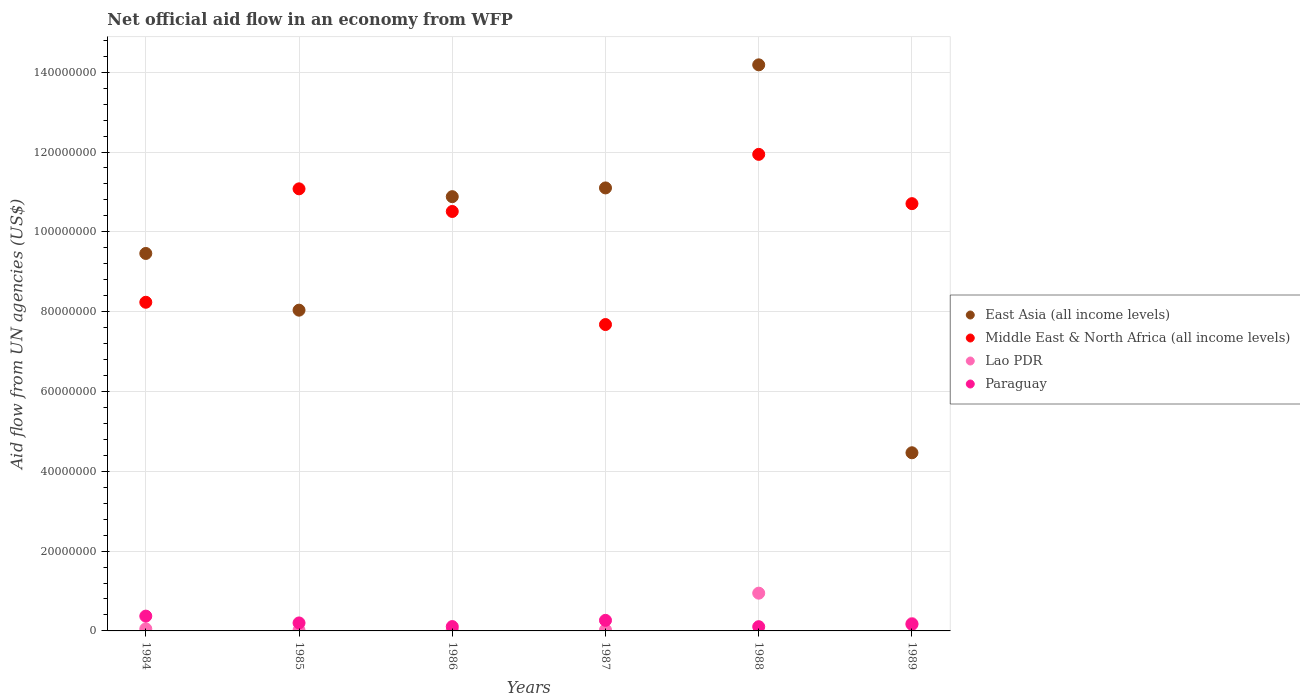Is the number of dotlines equal to the number of legend labels?
Make the answer very short. Yes. What is the net official aid flow in Paraguay in 1989?
Offer a terse response. 1.66e+06. Across all years, what is the maximum net official aid flow in Lao PDR?
Your answer should be very brief. 9.46e+06. Across all years, what is the minimum net official aid flow in Middle East & North Africa (all income levels)?
Your answer should be compact. 7.68e+07. In which year was the net official aid flow in Paraguay minimum?
Offer a terse response. 1988. What is the total net official aid flow in Lao PDR in the graph?
Offer a very short reply. 1.25e+07. What is the difference between the net official aid flow in Middle East & North Africa (all income levels) in 1987 and that in 1989?
Give a very brief answer. -3.03e+07. What is the difference between the net official aid flow in East Asia (all income levels) in 1984 and the net official aid flow in Middle East & North Africa (all income levels) in 1988?
Provide a succinct answer. -2.48e+07. What is the average net official aid flow in Lao PDR per year?
Ensure brevity in your answer.  2.09e+06. In the year 1986, what is the difference between the net official aid flow in East Asia (all income levels) and net official aid flow in Paraguay?
Offer a terse response. 1.08e+08. In how many years, is the net official aid flow in Middle East & North Africa (all income levels) greater than 128000000 US$?
Provide a succinct answer. 0. What is the ratio of the net official aid flow in Middle East & North Africa (all income levels) in 1986 to that in 1987?
Your answer should be compact. 1.37. Is the difference between the net official aid flow in East Asia (all income levels) in 1984 and 1987 greater than the difference between the net official aid flow in Paraguay in 1984 and 1987?
Make the answer very short. No. What is the difference between the highest and the second highest net official aid flow in Lao PDR?
Give a very brief answer. 7.60e+06. What is the difference between the highest and the lowest net official aid flow in Lao PDR?
Your response must be concise. 9.28e+06. In how many years, is the net official aid flow in Lao PDR greater than the average net official aid flow in Lao PDR taken over all years?
Give a very brief answer. 1. Does the net official aid flow in Middle East & North Africa (all income levels) monotonically increase over the years?
Provide a succinct answer. No. Is the net official aid flow in East Asia (all income levels) strictly greater than the net official aid flow in Middle East & North Africa (all income levels) over the years?
Your response must be concise. No. How many dotlines are there?
Provide a succinct answer. 4. How many years are there in the graph?
Offer a terse response. 6. What is the difference between two consecutive major ticks on the Y-axis?
Keep it short and to the point. 2.00e+07. Are the values on the major ticks of Y-axis written in scientific E-notation?
Provide a short and direct response. No. What is the title of the graph?
Keep it short and to the point. Net official aid flow in an economy from WFP. Does "Niger" appear as one of the legend labels in the graph?
Your response must be concise. No. What is the label or title of the Y-axis?
Provide a short and direct response. Aid flow from UN agencies (US$). What is the Aid flow from UN agencies (US$) of East Asia (all income levels) in 1984?
Keep it short and to the point. 9.46e+07. What is the Aid flow from UN agencies (US$) in Middle East & North Africa (all income levels) in 1984?
Offer a terse response. 8.24e+07. What is the Aid flow from UN agencies (US$) in Lao PDR in 1984?
Give a very brief answer. 5.20e+05. What is the Aid flow from UN agencies (US$) of Paraguay in 1984?
Your answer should be compact. 3.71e+06. What is the Aid flow from UN agencies (US$) in East Asia (all income levels) in 1985?
Ensure brevity in your answer.  8.04e+07. What is the Aid flow from UN agencies (US$) in Middle East & North Africa (all income levels) in 1985?
Make the answer very short. 1.11e+08. What is the Aid flow from UN agencies (US$) in Lao PDR in 1985?
Keep it short and to the point. 1.80e+05. What is the Aid flow from UN agencies (US$) of Paraguay in 1985?
Ensure brevity in your answer.  2.00e+06. What is the Aid flow from UN agencies (US$) in East Asia (all income levels) in 1986?
Keep it short and to the point. 1.09e+08. What is the Aid flow from UN agencies (US$) in Middle East & North Africa (all income levels) in 1986?
Your response must be concise. 1.05e+08. What is the Aid flow from UN agencies (US$) in Lao PDR in 1986?
Provide a succinct answer. 2.60e+05. What is the Aid flow from UN agencies (US$) of Paraguay in 1986?
Offer a terse response. 1.09e+06. What is the Aid flow from UN agencies (US$) of East Asia (all income levels) in 1987?
Your response must be concise. 1.11e+08. What is the Aid flow from UN agencies (US$) of Middle East & North Africa (all income levels) in 1987?
Ensure brevity in your answer.  7.68e+07. What is the Aid flow from UN agencies (US$) in Lao PDR in 1987?
Provide a short and direct response. 2.50e+05. What is the Aid flow from UN agencies (US$) in Paraguay in 1987?
Provide a succinct answer. 2.65e+06. What is the Aid flow from UN agencies (US$) of East Asia (all income levels) in 1988?
Your answer should be compact. 1.42e+08. What is the Aid flow from UN agencies (US$) in Middle East & North Africa (all income levels) in 1988?
Ensure brevity in your answer.  1.19e+08. What is the Aid flow from UN agencies (US$) in Lao PDR in 1988?
Make the answer very short. 9.46e+06. What is the Aid flow from UN agencies (US$) in Paraguay in 1988?
Your answer should be compact. 1.06e+06. What is the Aid flow from UN agencies (US$) in East Asia (all income levels) in 1989?
Ensure brevity in your answer.  4.46e+07. What is the Aid flow from UN agencies (US$) in Middle East & North Africa (all income levels) in 1989?
Offer a terse response. 1.07e+08. What is the Aid flow from UN agencies (US$) of Lao PDR in 1989?
Give a very brief answer. 1.86e+06. What is the Aid flow from UN agencies (US$) of Paraguay in 1989?
Your answer should be very brief. 1.66e+06. Across all years, what is the maximum Aid flow from UN agencies (US$) of East Asia (all income levels)?
Keep it short and to the point. 1.42e+08. Across all years, what is the maximum Aid flow from UN agencies (US$) in Middle East & North Africa (all income levels)?
Your response must be concise. 1.19e+08. Across all years, what is the maximum Aid flow from UN agencies (US$) in Lao PDR?
Your response must be concise. 9.46e+06. Across all years, what is the maximum Aid flow from UN agencies (US$) of Paraguay?
Provide a succinct answer. 3.71e+06. Across all years, what is the minimum Aid flow from UN agencies (US$) in East Asia (all income levels)?
Keep it short and to the point. 4.46e+07. Across all years, what is the minimum Aid flow from UN agencies (US$) of Middle East & North Africa (all income levels)?
Offer a terse response. 7.68e+07. Across all years, what is the minimum Aid flow from UN agencies (US$) in Paraguay?
Your answer should be compact. 1.06e+06. What is the total Aid flow from UN agencies (US$) in East Asia (all income levels) in the graph?
Your answer should be compact. 5.81e+08. What is the total Aid flow from UN agencies (US$) of Middle East & North Africa (all income levels) in the graph?
Your answer should be very brief. 6.01e+08. What is the total Aid flow from UN agencies (US$) of Lao PDR in the graph?
Provide a short and direct response. 1.25e+07. What is the total Aid flow from UN agencies (US$) of Paraguay in the graph?
Give a very brief answer. 1.22e+07. What is the difference between the Aid flow from UN agencies (US$) of East Asia (all income levels) in 1984 and that in 1985?
Your answer should be very brief. 1.42e+07. What is the difference between the Aid flow from UN agencies (US$) of Middle East & North Africa (all income levels) in 1984 and that in 1985?
Make the answer very short. -2.84e+07. What is the difference between the Aid flow from UN agencies (US$) of Paraguay in 1984 and that in 1985?
Your response must be concise. 1.71e+06. What is the difference between the Aid flow from UN agencies (US$) of East Asia (all income levels) in 1984 and that in 1986?
Your answer should be compact. -1.42e+07. What is the difference between the Aid flow from UN agencies (US$) in Middle East & North Africa (all income levels) in 1984 and that in 1986?
Give a very brief answer. -2.28e+07. What is the difference between the Aid flow from UN agencies (US$) in Paraguay in 1984 and that in 1986?
Offer a terse response. 2.62e+06. What is the difference between the Aid flow from UN agencies (US$) in East Asia (all income levels) in 1984 and that in 1987?
Give a very brief answer. -1.64e+07. What is the difference between the Aid flow from UN agencies (US$) of Middle East & North Africa (all income levels) in 1984 and that in 1987?
Provide a short and direct response. 5.58e+06. What is the difference between the Aid flow from UN agencies (US$) of Lao PDR in 1984 and that in 1987?
Provide a succinct answer. 2.70e+05. What is the difference between the Aid flow from UN agencies (US$) in Paraguay in 1984 and that in 1987?
Offer a terse response. 1.06e+06. What is the difference between the Aid flow from UN agencies (US$) in East Asia (all income levels) in 1984 and that in 1988?
Your answer should be very brief. -4.73e+07. What is the difference between the Aid flow from UN agencies (US$) in Middle East & North Africa (all income levels) in 1984 and that in 1988?
Make the answer very short. -3.71e+07. What is the difference between the Aid flow from UN agencies (US$) in Lao PDR in 1984 and that in 1988?
Your answer should be compact. -8.94e+06. What is the difference between the Aid flow from UN agencies (US$) of Paraguay in 1984 and that in 1988?
Make the answer very short. 2.65e+06. What is the difference between the Aid flow from UN agencies (US$) in East Asia (all income levels) in 1984 and that in 1989?
Your answer should be very brief. 4.99e+07. What is the difference between the Aid flow from UN agencies (US$) in Middle East & North Africa (all income levels) in 1984 and that in 1989?
Ensure brevity in your answer.  -2.47e+07. What is the difference between the Aid flow from UN agencies (US$) in Lao PDR in 1984 and that in 1989?
Provide a succinct answer. -1.34e+06. What is the difference between the Aid flow from UN agencies (US$) of Paraguay in 1984 and that in 1989?
Make the answer very short. 2.05e+06. What is the difference between the Aid flow from UN agencies (US$) of East Asia (all income levels) in 1985 and that in 1986?
Your answer should be compact. -2.84e+07. What is the difference between the Aid flow from UN agencies (US$) of Middle East & North Africa (all income levels) in 1985 and that in 1986?
Your response must be concise. 5.67e+06. What is the difference between the Aid flow from UN agencies (US$) in Paraguay in 1985 and that in 1986?
Your answer should be compact. 9.10e+05. What is the difference between the Aid flow from UN agencies (US$) in East Asia (all income levels) in 1985 and that in 1987?
Offer a very short reply. -3.06e+07. What is the difference between the Aid flow from UN agencies (US$) in Middle East & North Africa (all income levels) in 1985 and that in 1987?
Your response must be concise. 3.40e+07. What is the difference between the Aid flow from UN agencies (US$) of Lao PDR in 1985 and that in 1987?
Your answer should be compact. -7.00e+04. What is the difference between the Aid flow from UN agencies (US$) in Paraguay in 1985 and that in 1987?
Offer a terse response. -6.50e+05. What is the difference between the Aid flow from UN agencies (US$) of East Asia (all income levels) in 1985 and that in 1988?
Make the answer very short. -6.15e+07. What is the difference between the Aid flow from UN agencies (US$) in Middle East & North Africa (all income levels) in 1985 and that in 1988?
Provide a short and direct response. -8.64e+06. What is the difference between the Aid flow from UN agencies (US$) in Lao PDR in 1985 and that in 1988?
Make the answer very short. -9.28e+06. What is the difference between the Aid flow from UN agencies (US$) of Paraguay in 1985 and that in 1988?
Offer a terse response. 9.40e+05. What is the difference between the Aid flow from UN agencies (US$) in East Asia (all income levels) in 1985 and that in 1989?
Offer a very short reply. 3.57e+07. What is the difference between the Aid flow from UN agencies (US$) of Middle East & North Africa (all income levels) in 1985 and that in 1989?
Your answer should be compact. 3.71e+06. What is the difference between the Aid flow from UN agencies (US$) of Lao PDR in 1985 and that in 1989?
Provide a short and direct response. -1.68e+06. What is the difference between the Aid flow from UN agencies (US$) in Paraguay in 1985 and that in 1989?
Give a very brief answer. 3.40e+05. What is the difference between the Aid flow from UN agencies (US$) in East Asia (all income levels) in 1986 and that in 1987?
Provide a succinct answer. -2.19e+06. What is the difference between the Aid flow from UN agencies (US$) in Middle East & North Africa (all income levels) in 1986 and that in 1987?
Your answer should be very brief. 2.83e+07. What is the difference between the Aid flow from UN agencies (US$) of Paraguay in 1986 and that in 1987?
Ensure brevity in your answer.  -1.56e+06. What is the difference between the Aid flow from UN agencies (US$) of East Asia (all income levels) in 1986 and that in 1988?
Your response must be concise. -3.30e+07. What is the difference between the Aid flow from UN agencies (US$) in Middle East & North Africa (all income levels) in 1986 and that in 1988?
Provide a succinct answer. -1.43e+07. What is the difference between the Aid flow from UN agencies (US$) in Lao PDR in 1986 and that in 1988?
Make the answer very short. -9.20e+06. What is the difference between the Aid flow from UN agencies (US$) in East Asia (all income levels) in 1986 and that in 1989?
Offer a very short reply. 6.42e+07. What is the difference between the Aid flow from UN agencies (US$) in Middle East & North Africa (all income levels) in 1986 and that in 1989?
Offer a terse response. -1.96e+06. What is the difference between the Aid flow from UN agencies (US$) in Lao PDR in 1986 and that in 1989?
Ensure brevity in your answer.  -1.60e+06. What is the difference between the Aid flow from UN agencies (US$) of Paraguay in 1986 and that in 1989?
Provide a short and direct response. -5.70e+05. What is the difference between the Aid flow from UN agencies (US$) in East Asia (all income levels) in 1987 and that in 1988?
Your response must be concise. -3.08e+07. What is the difference between the Aid flow from UN agencies (US$) in Middle East & North Africa (all income levels) in 1987 and that in 1988?
Your response must be concise. -4.26e+07. What is the difference between the Aid flow from UN agencies (US$) in Lao PDR in 1987 and that in 1988?
Provide a succinct answer. -9.21e+06. What is the difference between the Aid flow from UN agencies (US$) of Paraguay in 1987 and that in 1988?
Offer a very short reply. 1.59e+06. What is the difference between the Aid flow from UN agencies (US$) of East Asia (all income levels) in 1987 and that in 1989?
Your response must be concise. 6.64e+07. What is the difference between the Aid flow from UN agencies (US$) in Middle East & North Africa (all income levels) in 1987 and that in 1989?
Your answer should be compact. -3.03e+07. What is the difference between the Aid flow from UN agencies (US$) of Lao PDR in 1987 and that in 1989?
Your answer should be very brief. -1.61e+06. What is the difference between the Aid flow from UN agencies (US$) in Paraguay in 1987 and that in 1989?
Give a very brief answer. 9.90e+05. What is the difference between the Aid flow from UN agencies (US$) of East Asia (all income levels) in 1988 and that in 1989?
Your answer should be compact. 9.72e+07. What is the difference between the Aid flow from UN agencies (US$) of Middle East & North Africa (all income levels) in 1988 and that in 1989?
Keep it short and to the point. 1.24e+07. What is the difference between the Aid flow from UN agencies (US$) in Lao PDR in 1988 and that in 1989?
Your answer should be compact. 7.60e+06. What is the difference between the Aid flow from UN agencies (US$) in Paraguay in 1988 and that in 1989?
Provide a short and direct response. -6.00e+05. What is the difference between the Aid flow from UN agencies (US$) of East Asia (all income levels) in 1984 and the Aid flow from UN agencies (US$) of Middle East & North Africa (all income levels) in 1985?
Offer a terse response. -1.62e+07. What is the difference between the Aid flow from UN agencies (US$) of East Asia (all income levels) in 1984 and the Aid flow from UN agencies (US$) of Lao PDR in 1985?
Offer a terse response. 9.44e+07. What is the difference between the Aid flow from UN agencies (US$) in East Asia (all income levels) in 1984 and the Aid flow from UN agencies (US$) in Paraguay in 1985?
Your response must be concise. 9.26e+07. What is the difference between the Aid flow from UN agencies (US$) in Middle East & North Africa (all income levels) in 1984 and the Aid flow from UN agencies (US$) in Lao PDR in 1985?
Your answer should be very brief. 8.22e+07. What is the difference between the Aid flow from UN agencies (US$) in Middle East & North Africa (all income levels) in 1984 and the Aid flow from UN agencies (US$) in Paraguay in 1985?
Your answer should be very brief. 8.04e+07. What is the difference between the Aid flow from UN agencies (US$) of Lao PDR in 1984 and the Aid flow from UN agencies (US$) of Paraguay in 1985?
Provide a succinct answer. -1.48e+06. What is the difference between the Aid flow from UN agencies (US$) of East Asia (all income levels) in 1984 and the Aid flow from UN agencies (US$) of Middle East & North Africa (all income levels) in 1986?
Ensure brevity in your answer.  -1.05e+07. What is the difference between the Aid flow from UN agencies (US$) of East Asia (all income levels) in 1984 and the Aid flow from UN agencies (US$) of Lao PDR in 1986?
Ensure brevity in your answer.  9.43e+07. What is the difference between the Aid flow from UN agencies (US$) in East Asia (all income levels) in 1984 and the Aid flow from UN agencies (US$) in Paraguay in 1986?
Provide a short and direct response. 9.35e+07. What is the difference between the Aid flow from UN agencies (US$) of Middle East & North Africa (all income levels) in 1984 and the Aid flow from UN agencies (US$) of Lao PDR in 1986?
Provide a short and direct response. 8.21e+07. What is the difference between the Aid flow from UN agencies (US$) in Middle East & North Africa (all income levels) in 1984 and the Aid flow from UN agencies (US$) in Paraguay in 1986?
Ensure brevity in your answer.  8.13e+07. What is the difference between the Aid flow from UN agencies (US$) of Lao PDR in 1984 and the Aid flow from UN agencies (US$) of Paraguay in 1986?
Give a very brief answer. -5.70e+05. What is the difference between the Aid flow from UN agencies (US$) in East Asia (all income levels) in 1984 and the Aid flow from UN agencies (US$) in Middle East & North Africa (all income levels) in 1987?
Make the answer very short. 1.78e+07. What is the difference between the Aid flow from UN agencies (US$) of East Asia (all income levels) in 1984 and the Aid flow from UN agencies (US$) of Lao PDR in 1987?
Make the answer very short. 9.43e+07. What is the difference between the Aid flow from UN agencies (US$) in East Asia (all income levels) in 1984 and the Aid flow from UN agencies (US$) in Paraguay in 1987?
Offer a very short reply. 9.19e+07. What is the difference between the Aid flow from UN agencies (US$) in Middle East & North Africa (all income levels) in 1984 and the Aid flow from UN agencies (US$) in Lao PDR in 1987?
Provide a succinct answer. 8.21e+07. What is the difference between the Aid flow from UN agencies (US$) in Middle East & North Africa (all income levels) in 1984 and the Aid flow from UN agencies (US$) in Paraguay in 1987?
Your answer should be compact. 7.97e+07. What is the difference between the Aid flow from UN agencies (US$) of Lao PDR in 1984 and the Aid flow from UN agencies (US$) of Paraguay in 1987?
Give a very brief answer. -2.13e+06. What is the difference between the Aid flow from UN agencies (US$) in East Asia (all income levels) in 1984 and the Aid flow from UN agencies (US$) in Middle East & North Africa (all income levels) in 1988?
Provide a short and direct response. -2.48e+07. What is the difference between the Aid flow from UN agencies (US$) in East Asia (all income levels) in 1984 and the Aid flow from UN agencies (US$) in Lao PDR in 1988?
Provide a succinct answer. 8.51e+07. What is the difference between the Aid flow from UN agencies (US$) in East Asia (all income levels) in 1984 and the Aid flow from UN agencies (US$) in Paraguay in 1988?
Offer a terse response. 9.35e+07. What is the difference between the Aid flow from UN agencies (US$) of Middle East & North Africa (all income levels) in 1984 and the Aid flow from UN agencies (US$) of Lao PDR in 1988?
Your response must be concise. 7.29e+07. What is the difference between the Aid flow from UN agencies (US$) of Middle East & North Africa (all income levels) in 1984 and the Aid flow from UN agencies (US$) of Paraguay in 1988?
Your answer should be compact. 8.13e+07. What is the difference between the Aid flow from UN agencies (US$) of Lao PDR in 1984 and the Aid flow from UN agencies (US$) of Paraguay in 1988?
Your answer should be compact. -5.40e+05. What is the difference between the Aid flow from UN agencies (US$) in East Asia (all income levels) in 1984 and the Aid flow from UN agencies (US$) in Middle East & North Africa (all income levels) in 1989?
Offer a terse response. -1.25e+07. What is the difference between the Aid flow from UN agencies (US$) in East Asia (all income levels) in 1984 and the Aid flow from UN agencies (US$) in Lao PDR in 1989?
Make the answer very short. 9.27e+07. What is the difference between the Aid flow from UN agencies (US$) of East Asia (all income levels) in 1984 and the Aid flow from UN agencies (US$) of Paraguay in 1989?
Make the answer very short. 9.29e+07. What is the difference between the Aid flow from UN agencies (US$) of Middle East & North Africa (all income levels) in 1984 and the Aid flow from UN agencies (US$) of Lao PDR in 1989?
Offer a terse response. 8.05e+07. What is the difference between the Aid flow from UN agencies (US$) in Middle East & North Africa (all income levels) in 1984 and the Aid flow from UN agencies (US$) in Paraguay in 1989?
Keep it short and to the point. 8.07e+07. What is the difference between the Aid flow from UN agencies (US$) in Lao PDR in 1984 and the Aid flow from UN agencies (US$) in Paraguay in 1989?
Your response must be concise. -1.14e+06. What is the difference between the Aid flow from UN agencies (US$) of East Asia (all income levels) in 1985 and the Aid flow from UN agencies (US$) of Middle East & North Africa (all income levels) in 1986?
Offer a terse response. -2.47e+07. What is the difference between the Aid flow from UN agencies (US$) in East Asia (all income levels) in 1985 and the Aid flow from UN agencies (US$) in Lao PDR in 1986?
Your response must be concise. 8.01e+07. What is the difference between the Aid flow from UN agencies (US$) in East Asia (all income levels) in 1985 and the Aid flow from UN agencies (US$) in Paraguay in 1986?
Offer a terse response. 7.93e+07. What is the difference between the Aid flow from UN agencies (US$) of Middle East & North Africa (all income levels) in 1985 and the Aid flow from UN agencies (US$) of Lao PDR in 1986?
Ensure brevity in your answer.  1.11e+08. What is the difference between the Aid flow from UN agencies (US$) in Middle East & North Africa (all income levels) in 1985 and the Aid flow from UN agencies (US$) in Paraguay in 1986?
Provide a short and direct response. 1.10e+08. What is the difference between the Aid flow from UN agencies (US$) in Lao PDR in 1985 and the Aid flow from UN agencies (US$) in Paraguay in 1986?
Ensure brevity in your answer.  -9.10e+05. What is the difference between the Aid flow from UN agencies (US$) of East Asia (all income levels) in 1985 and the Aid flow from UN agencies (US$) of Middle East & North Africa (all income levels) in 1987?
Your response must be concise. 3.60e+06. What is the difference between the Aid flow from UN agencies (US$) in East Asia (all income levels) in 1985 and the Aid flow from UN agencies (US$) in Lao PDR in 1987?
Offer a very short reply. 8.01e+07. What is the difference between the Aid flow from UN agencies (US$) of East Asia (all income levels) in 1985 and the Aid flow from UN agencies (US$) of Paraguay in 1987?
Offer a terse response. 7.77e+07. What is the difference between the Aid flow from UN agencies (US$) in Middle East & North Africa (all income levels) in 1985 and the Aid flow from UN agencies (US$) in Lao PDR in 1987?
Give a very brief answer. 1.11e+08. What is the difference between the Aid flow from UN agencies (US$) of Middle East & North Africa (all income levels) in 1985 and the Aid flow from UN agencies (US$) of Paraguay in 1987?
Provide a succinct answer. 1.08e+08. What is the difference between the Aid flow from UN agencies (US$) in Lao PDR in 1985 and the Aid flow from UN agencies (US$) in Paraguay in 1987?
Give a very brief answer. -2.47e+06. What is the difference between the Aid flow from UN agencies (US$) in East Asia (all income levels) in 1985 and the Aid flow from UN agencies (US$) in Middle East & North Africa (all income levels) in 1988?
Your response must be concise. -3.90e+07. What is the difference between the Aid flow from UN agencies (US$) in East Asia (all income levels) in 1985 and the Aid flow from UN agencies (US$) in Lao PDR in 1988?
Ensure brevity in your answer.  7.09e+07. What is the difference between the Aid flow from UN agencies (US$) of East Asia (all income levels) in 1985 and the Aid flow from UN agencies (US$) of Paraguay in 1988?
Ensure brevity in your answer.  7.93e+07. What is the difference between the Aid flow from UN agencies (US$) of Middle East & North Africa (all income levels) in 1985 and the Aid flow from UN agencies (US$) of Lao PDR in 1988?
Offer a terse response. 1.01e+08. What is the difference between the Aid flow from UN agencies (US$) of Middle East & North Africa (all income levels) in 1985 and the Aid flow from UN agencies (US$) of Paraguay in 1988?
Provide a succinct answer. 1.10e+08. What is the difference between the Aid flow from UN agencies (US$) of Lao PDR in 1985 and the Aid flow from UN agencies (US$) of Paraguay in 1988?
Your answer should be compact. -8.80e+05. What is the difference between the Aid flow from UN agencies (US$) in East Asia (all income levels) in 1985 and the Aid flow from UN agencies (US$) in Middle East & North Africa (all income levels) in 1989?
Provide a succinct answer. -2.67e+07. What is the difference between the Aid flow from UN agencies (US$) in East Asia (all income levels) in 1985 and the Aid flow from UN agencies (US$) in Lao PDR in 1989?
Give a very brief answer. 7.85e+07. What is the difference between the Aid flow from UN agencies (US$) in East Asia (all income levels) in 1985 and the Aid flow from UN agencies (US$) in Paraguay in 1989?
Give a very brief answer. 7.87e+07. What is the difference between the Aid flow from UN agencies (US$) in Middle East & North Africa (all income levels) in 1985 and the Aid flow from UN agencies (US$) in Lao PDR in 1989?
Ensure brevity in your answer.  1.09e+08. What is the difference between the Aid flow from UN agencies (US$) of Middle East & North Africa (all income levels) in 1985 and the Aid flow from UN agencies (US$) of Paraguay in 1989?
Provide a succinct answer. 1.09e+08. What is the difference between the Aid flow from UN agencies (US$) of Lao PDR in 1985 and the Aid flow from UN agencies (US$) of Paraguay in 1989?
Your answer should be compact. -1.48e+06. What is the difference between the Aid flow from UN agencies (US$) in East Asia (all income levels) in 1986 and the Aid flow from UN agencies (US$) in Middle East & North Africa (all income levels) in 1987?
Make the answer very short. 3.20e+07. What is the difference between the Aid flow from UN agencies (US$) in East Asia (all income levels) in 1986 and the Aid flow from UN agencies (US$) in Lao PDR in 1987?
Give a very brief answer. 1.09e+08. What is the difference between the Aid flow from UN agencies (US$) in East Asia (all income levels) in 1986 and the Aid flow from UN agencies (US$) in Paraguay in 1987?
Provide a succinct answer. 1.06e+08. What is the difference between the Aid flow from UN agencies (US$) in Middle East & North Africa (all income levels) in 1986 and the Aid flow from UN agencies (US$) in Lao PDR in 1987?
Offer a terse response. 1.05e+08. What is the difference between the Aid flow from UN agencies (US$) of Middle East & North Africa (all income levels) in 1986 and the Aid flow from UN agencies (US$) of Paraguay in 1987?
Your answer should be compact. 1.02e+08. What is the difference between the Aid flow from UN agencies (US$) of Lao PDR in 1986 and the Aid flow from UN agencies (US$) of Paraguay in 1987?
Offer a terse response. -2.39e+06. What is the difference between the Aid flow from UN agencies (US$) of East Asia (all income levels) in 1986 and the Aid flow from UN agencies (US$) of Middle East & North Africa (all income levels) in 1988?
Provide a short and direct response. -1.06e+07. What is the difference between the Aid flow from UN agencies (US$) in East Asia (all income levels) in 1986 and the Aid flow from UN agencies (US$) in Lao PDR in 1988?
Provide a succinct answer. 9.94e+07. What is the difference between the Aid flow from UN agencies (US$) of East Asia (all income levels) in 1986 and the Aid flow from UN agencies (US$) of Paraguay in 1988?
Your response must be concise. 1.08e+08. What is the difference between the Aid flow from UN agencies (US$) in Middle East & North Africa (all income levels) in 1986 and the Aid flow from UN agencies (US$) in Lao PDR in 1988?
Offer a very short reply. 9.56e+07. What is the difference between the Aid flow from UN agencies (US$) in Middle East & North Africa (all income levels) in 1986 and the Aid flow from UN agencies (US$) in Paraguay in 1988?
Your response must be concise. 1.04e+08. What is the difference between the Aid flow from UN agencies (US$) of Lao PDR in 1986 and the Aid flow from UN agencies (US$) of Paraguay in 1988?
Your answer should be compact. -8.00e+05. What is the difference between the Aid flow from UN agencies (US$) in East Asia (all income levels) in 1986 and the Aid flow from UN agencies (US$) in Middle East & North Africa (all income levels) in 1989?
Your answer should be compact. 1.75e+06. What is the difference between the Aid flow from UN agencies (US$) in East Asia (all income levels) in 1986 and the Aid flow from UN agencies (US$) in Lao PDR in 1989?
Make the answer very short. 1.07e+08. What is the difference between the Aid flow from UN agencies (US$) of East Asia (all income levels) in 1986 and the Aid flow from UN agencies (US$) of Paraguay in 1989?
Provide a succinct answer. 1.07e+08. What is the difference between the Aid flow from UN agencies (US$) in Middle East & North Africa (all income levels) in 1986 and the Aid flow from UN agencies (US$) in Lao PDR in 1989?
Make the answer very short. 1.03e+08. What is the difference between the Aid flow from UN agencies (US$) in Middle East & North Africa (all income levels) in 1986 and the Aid flow from UN agencies (US$) in Paraguay in 1989?
Offer a very short reply. 1.03e+08. What is the difference between the Aid flow from UN agencies (US$) in Lao PDR in 1986 and the Aid flow from UN agencies (US$) in Paraguay in 1989?
Your response must be concise. -1.40e+06. What is the difference between the Aid flow from UN agencies (US$) in East Asia (all income levels) in 1987 and the Aid flow from UN agencies (US$) in Middle East & North Africa (all income levels) in 1988?
Keep it short and to the point. -8.41e+06. What is the difference between the Aid flow from UN agencies (US$) of East Asia (all income levels) in 1987 and the Aid flow from UN agencies (US$) of Lao PDR in 1988?
Give a very brief answer. 1.02e+08. What is the difference between the Aid flow from UN agencies (US$) of East Asia (all income levels) in 1987 and the Aid flow from UN agencies (US$) of Paraguay in 1988?
Your answer should be very brief. 1.10e+08. What is the difference between the Aid flow from UN agencies (US$) of Middle East & North Africa (all income levels) in 1987 and the Aid flow from UN agencies (US$) of Lao PDR in 1988?
Offer a very short reply. 6.73e+07. What is the difference between the Aid flow from UN agencies (US$) of Middle East & North Africa (all income levels) in 1987 and the Aid flow from UN agencies (US$) of Paraguay in 1988?
Give a very brief answer. 7.57e+07. What is the difference between the Aid flow from UN agencies (US$) of Lao PDR in 1987 and the Aid flow from UN agencies (US$) of Paraguay in 1988?
Provide a succinct answer. -8.10e+05. What is the difference between the Aid flow from UN agencies (US$) of East Asia (all income levels) in 1987 and the Aid flow from UN agencies (US$) of Middle East & North Africa (all income levels) in 1989?
Provide a short and direct response. 3.94e+06. What is the difference between the Aid flow from UN agencies (US$) of East Asia (all income levels) in 1987 and the Aid flow from UN agencies (US$) of Lao PDR in 1989?
Your answer should be very brief. 1.09e+08. What is the difference between the Aid flow from UN agencies (US$) of East Asia (all income levels) in 1987 and the Aid flow from UN agencies (US$) of Paraguay in 1989?
Give a very brief answer. 1.09e+08. What is the difference between the Aid flow from UN agencies (US$) in Middle East & North Africa (all income levels) in 1987 and the Aid flow from UN agencies (US$) in Lao PDR in 1989?
Give a very brief answer. 7.49e+07. What is the difference between the Aid flow from UN agencies (US$) of Middle East & North Africa (all income levels) in 1987 and the Aid flow from UN agencies (US$) of Paraguay in 1989?
Offer a very short reply. 7.51e+07. What is the difference between the Aid flow from UN agencies (US$) of Lao PDR in 1987 and the Aid flow from UN agencies (US$) of Paraguay in 1989?
Provide a succinct answer. -1.41e+06. What is the difference between the Aid flow from UN agencies (US$) in East Asia (all income levels) in 1988 and the Aid flow from UN agencies (US$) in Middle East & North Africa (all income levels) in 1989?
Offer a very short reply. 3.48e+07. What is the difference between the Aid flow from UN agencies (US$) of East Asia (all income levels) in 1988 and the Aid flow from UN agencies (US$) of Lao PDR in 1989?
Keep it short and to the point. 1.40e+08. What is the difference between the Aid flow from UN agencies (US$) in East Asia (all income levels) in 1988 and the Aid flow from UN agencies (US$) in Paraguay in 1989?
Give a very brief answer. 1.40e+08. What is the difference between the Aid flow from UN agencies (US$) of Middle East & North Africa (all income levels) in 1988 and the Aid flow from UN agencies (US$) of Lao PDR in 1989?
Provide a succinct answer. 1.18e+08. What is the difference between the Aid flow from UN agencies (US$) of Middle East & North Africa (all income levels) in 1988 and the Aid flow from UN agencies (US$) of Paraguay in 1989?
Make the answer very short. 1.18e+08. What is the difference between the Aid flow from UN agencies (US$) in Lao PDR in 1988 and the Aid flow from UN agencies (US$) in Paraguay in 1989?
Provide a short and direct response. 7.80e+06. What is the average Aid flow from UN agencies (US$) in East Asia (all income levels) per year?
Your answer should be very brief. 9.69e+07. What is the average Aid flow from UN agencies (US$) in Middle East & North Africa (all income levels) per year?
Ensure brevity in your answer.  1.00e+08. What is the average Aid flow from UN agencies (US$) in Lao PDR per year?
Make the answer very short. 2.09e+06. What is the average Aid flow from UN agencies (US$) in Paraguay per year?
Offer a terse response. 2.03e+06. In the year 1984, what is the difference between the Aid flow from UN agencies (US$) of East Asia (all income levels) and Aid flow from UN agencies (US$) of Middle East & North Africa (all income levels)?
Keep it short and to the point. 1.22e+07. In the year 1984, what is the difference between the Aid flow from UN agencies (US$) in East Asia (all income levels) and Aid flow from UN agencies (US$) in Lao PDR?
Provide a short and direct response. 9.41e+07. In the year 1984, what is the difference between the Aid flow from UN agencies (US$) of East Asia (all income levels) and Aid flow from UN agencies (US$) of Paraguay?
Keep it short and to the point. 9.09e+07. In the year 1984, what is the difference between the Aid flow from UN agencies (US$) in Middle East & North Africa (all income levels) and Aid flow from UN agencies (US$) in Lao PDR?
Make the answer very short. 8.18e+07. In the year 1984, what is the difference between the Aid flow from UN agencies (US$) in Middle East & North Africa (all income levels) and Aid flow from UN agencies (US$) in Paraguay?
Provide a succinct answer. 7.86e+07. In the year 1984, what is the difference between the Aid flow from UN agencies (US$) in Lao PDR and Aid flow from UN agencies (US$) in Paraguay?
Provide a succinct answer. -3.19e+06. In the year 1985, what is the difference between the Aid flow from UN agencies (US$) of East Asia (all income levels) and Aid flow from UN agencies (US$) of Middle East & North Africa (all income levels)?
Keep it short and to the point. -3.04e+07. In the year 1985, what is the difference between the Aid flow from UN agencies (US$) of East Asia (all income levels) and Aid flow from UN agencies (US$) of Lao PDR?
Make the answer very short. 8.02e+07. In the year 1985, what is the difference between the Aid flow from UN agencies (US$) of East Asia (all income levels) and Aid flow from UN agencies (US$) of Paraguay?
Offer a very short reply. 7.84e+07. In the year 1985, what is the difference between the Aid flow from UN agencies (US$) in Middle East & North Africa (all income levels) and Aid flow from UN agencies (US$) in Lao PDR?
Provide a short and direct response. 1.11e+08. In the year 1985, what is the difference between the Aid flow from UN agencies (US$) in Middle East & North Africa (all income levels) and Aid flow from UN agencies (US$) in Paraguay?
Give a very brief answer. 1.09e+08. In the year 1985, what is the difference between the Aid flow from UN agencies (US$) of Lao PDR and Aid flow from UN agencies (US$) of Paraguay?
Offer a very short reply. -1.82e+06. In the year 1986, what is the difference between the Aid flow from UN agencies (US$) of East Asia (all income levels) and Aid flow from UN agencies (US$) of Middle East & North Africa (all income levels)?
Make the answer very short. 3.71e+06. In the year 1986, what is the difference between the Aid flow from UN agencies (US$) of East Asia (all income levels) and Aid flow from UN agencies (US$) of Lao PDR?
Your answer should be compact. 1.09e+08. In the year 1986, what is the difference between the Aid flow from UN agencies (US$) of East Asia (all income levels) and Aid flow from UN agencies (US$) of Paraguay?
Your answer should be compact. 1.08e+08. In the year 1986, what is the difference between the Aid flow from UN agencies (US$) of Middle East & North Africa (all income levels) and Aid flow from UN agencies (US$) of Lao PDR?
Your answer should be compact. 1.05e+08. In the year 1986, what is the difference between the Aid flow from UN agencies (US$) of Middle East & North Africa (all income levels) and Aid flow from UN agencies (US$) of Paraguay?
Provide a short and direct response. 1.04e+08. In the year 1986, what is the difference between the Aid flow from UN agencies (US$) of Lao PDR and Aid flow from UN agencies (US$) of Paraguay?
Your answer should be very brief. -8.30e+05. In the year 1987, what is the difference between the Aid flow from UN agencies (US$) in East Asia (all income levels) and Aid flow from UN agencies (US$) in Middle East & North Africa (all income levels)?
Your answer should be compact. 3.42e+07. In the year 1987, what is the difference between the Aid flow from UN agencies (US$) of East Asia (all income levels) and Aid flow from UN agencies (US$) of Lao PDR?
Give a very brief answer. 1.11e+08. In the year 1987, what is the difference between the Aid flow from UN agencies (US$) of East Asia (all income levels) and Aid flow from UN agencies (US$) of Paraguay?
Provide a succinct answer. 1.08e+08. In the year 1987, what is the difference between the Aid flow from UN agencies (US$) of Middle East & North Africa (all income levels) and Aid flow from UN agencies (US$) of Lao PDR?
Provide a short and direct response. 7.65e+07. In the year 1987, what is the difference between the Aid flow from UN agencies (US$) of Middle East & North Africa (all income levels) and Aid flow from UN agencies (US$) of Paraguay?
Provide a succinct answer. 7.41e+07. In the year 1987, what is the difference between the Aid flow from UN agencies (US$) of Lao PDR and Aid flow from UN agencies (US$) of Paraguay?
Provide a short and direct response. -2.40e+06. In the year 1988, what is the difference between the Aid flow from UN agencies (US$) in East Asia (all income levels) and Aid flow from UN agencies (US$) in Middle East & North Africa (all income levels)?
Offer a very short reply. 2.24e+07. In the year 1988, what is the difference between the Aid flow from UN agencies (US$) in East Asia (all income levels) and Aid flow from UN agencies (US$) in Lao PDR?
Keep it short and to the point. 1.32e+08. In the year 1988, what is the difference between the Aid flow from UN agencies (US$) of East Asia (all income levels) and Aid flow from UN agencies (US$) of Paraguay?
Provide a short and direct response. 1.41e+08. In the year 1988, what is the difference between the Aid flow from UN agencies (US$) in Middle East & North Africa (all income levels) and Aid flow from UN agencies (US$) in Lao PDR?
Provide a short and direct response. 1.10e+08. In the year 1988, what is the difference between the Aid flow from UN agencies (US$) in Middle East & North Africa (all income levels) and Aid flow from UN agencies (US$) in Paraguay?
Make the answer very short. 1.18e+08. In the year 1988, what is the difference between the Aid flow from UN agencies (US$) in Lao PDR and Aid flow from UN agencies (US$) in Paraguay?
Your answer should be compact. 8.40e+06. In the year 1989, what is the difference between the Aid flow from UN agencies (US$) in East Asia (all income levels) and Aid flow from UN agencies (US$) in Middle East & North Africa (all income levels)?
Your answer should be compact. -6.24e+07. In the year 1989, what is the difference between the Aid flow from UN agencies (US$) of East Asia (all income levels) and Aid flow from UN agencies (US$) of Lao PDR?
Offer a very short reply. 4.28e+07. In the year 1989, what is the difference between the Aid flow from UN agencies (US$) of East Asia (all income levels) and Aid flow from UN agencies (US$) of Paraguay?
Keep it short and to the point. 4.30e+07. In the year 1989, what is the difference between the Aid flow from UN agencies (US$) of Middle East & North Africa (all income levels) and Aid flow from UN agencies (US$) of Lao PDR?
Make the answer very short. 1.05e+08. In the year 1989, what is the difference between the Aid flow from UN agencies (US$) in Middle East & North Africa (all income levels) and Aid flow from UN agencies (US$) in Paraguay?
Offer a terse response. 1.05e+08. What is the ratio of the Aid flow from UN agencies (US$) in East Asia (all income levels) in 1984 to that in 1985?
Offer a very short reply. 1.18. What is the ratio of the Aid flow from UN agencies (US$) in Middle East & North Africa (all income levels) in 1984 to that in 1985?
Your answer should be very brief. 0.74. What is the ratio of the Aid flow from UN agencies (US$) in Lao PDR in 1984 to that in 1985?
Provide a short and direct response. 2.89. What is the ratio of the Aid flow from UN agencies (US$) in Paraguay in 1984 to that in 1985?
Offer a terse response. 1.85. What is the ratio of the Aid flow from UN agencies (US$) in East Asia (all income levels) in 1984 to that in 1986?
Provide a succinct answer. 0.87. What is the ratio of the Aid flow from UN agencies (US$) of Middle East & North Africa (all income levels) in 1984 to that in 1986?
Your answer should be very brief. 0.78. What is the ratio of the Aid flow from UN agencies (US$) of Lao PDR in 1984 to that in 1986?
Provide a short and direct response. 2. What is the ratio of the Aid flow from UN agencies (US$) of Paraguay in 1984 to that in 1986?
Make the answer very short. 3.4. What is the ratio of the Aid flow from UN agencies (US$) of East Asia (all income levels) in 1984 to that in 1987?
Ensure brevity in your answer.  0.85. What is the ratio of the Aid flow from UN agencies (US$) of Middle East & North Africa (all income levels) in 1984 to that in 1987?
Your response must be concise. 1.07. What is the ratio of the Aid flow from UN agencies (US$) in Lao PDR in 1984 to that in 1987?
Provide a short and direct response. 2.08. What is the ratio of the Aid flow from UN agencies (US$) in Paraguay in 1984 to that in 1987?
Make the answer very short. 1.4. What is the ratio of the Aid flow from UN agencies (US$) in East Asia (all income levels) in 1984 to that in 1988?
Make the answer very short. 0.67. What is the ratio of the Aid flow from UN agencies (US$) in Middle East & North Africa (all income levels) in 1984 to that in 1988?
Make the answer very short. 0.69. What is the ratio of the Aid flow from UN agencies (US$) in Lao PDR in 1984 to that in 1988?
Ensure brevity in your answer.  0.06. What is the ratio of the Aid flow from UN agencies (US$) in Paraguay in 1984 to that in 1988?
Provide a succinct answer. 3.5. What is the ratio of the Aid flow from UN agencies (US$) in East Asia (all income levels) in 1984 to that in 1989?
Your answer should be compact. 2.12. What is the ratio of the Aid flow from UN agencies (US$) of Middle East & North Africa (all income levels) in 1984 to that in 1989?
Give a very brief answer. 0.77. What is the ratio of the Aid flow from UN agencies (US$) in Lao PDR in 1984 to that in 1989?
Give a very brief answer. 0.28. What is the ratio of the Aid flow from UN agencies (US$) in Paraguay in 1984 to that in 1989?
Your answer should be very brief. 2.23. What is the ratio of the Aid flow from UN agencies (US$) of East Asia (all income levels) in 1985 to that in 1986?
Offer a terse response. 0.74. What is the ratio of the Aid flow from UN agencies (US$) in Middle East & North Africa (all income levels) in 1985 to that in 1986?
Provide a short and direct response. 1.05. What is the ratio of the Aid flow from UN agencies (US$) in Lao PDR in 1985 to that in 1986?
Ensure brevity in your answer.  0.69. What is the ratio of the Aid flow from UN agencies (US$) of Paraguay in 1985 to that in 1986?
Offer a very short reply. 1.83. What is the ratio of the Aid flow from UN agencies (US$) in East Asia (all income levels) in 1985 to that in 1987?
Your response must be concise. 0.72. What is the ratio of the Aid flow from UN agencies (US$) of Middle East & North Africa (all income levels) in 1985 to that in 1987?
Offer a terse response. 1.44. What is the ratio of the Aid flow from UN agencies (US$) in Lao PDR in 1985 to that in 1987?
Give a very brief answer. 0.72. What is the ratio of the Aid flow from UN agencies (US$) of Paraguay in 1985 to that in 1987?
Give a very brief answer. 0.75. What is the ratio of the Aid flow from UN agencies (US$) of East Asia (all income levels) in 1985 to that in 1988?
Ensure brevity in your answer.  0.57. What is the ratio of the Aid flow from UN agencies (US$) of Middle East & North Africa (all income levels) in 1985 to that in 1988?
Offer a very short reply. 0.93. What is the ratio of the Aid flow from UN agencies (US$) of Lao PDR in 1985 to that in 1988?
Provide a succinct answer. 0.02. What is the ratio of the Aid flow from UN agencies (US$) of Paraguay in 1985 to that in 1988?
Ensure brevity in your answer.  1.89. What is the ratio of the Aid flow from UN agencies (US$) in East Asia (all income levels) in 1985 to that in 1989?
Your answer should be compact. 1.8. What is the ratio of the Aid flow from UN agencies (US$) of Middle East & North Africa (all income levels) in 1985 to that in 1989?
Provide a short and direct response. 1.03. What is the ratio of the Aid flow from UN agencies (US$) of Lao PDR in 1985 to that in 1989?
Your answer should be very brief. 0.1. What is the ratio of the Aid flow from UN agencies (US$) of Paraguay in 1985 to that in 1989?
Ensure brevity in your answer.  1.2. What is the ratio of the Aid flow from UN agencies (US$) in East Asia (all income levels) in 1986 to that in 1987?
Provide a succinct answer. 0.98. What is the ratio of the Aid flow from UN agencies (US$) of Middle East & North Africa (all income levels) in 1986 to that in 1987?
Keep it short and to the point. 1.37. What is the ratio of the Aid flow from UN agencies (US$) in Paraguay in 1986 to that in 1987?
Provide a short and direct response. 0.41. What is the ratio of the Aid flow from UN agencies (US$) of East Asia (all income levels) in 1986 to that in 1988?
Your response must be concise. 0.77. What is the ratio of the Aid flow from UN agencies (US$) of Middle East & North Africa (all income levels) in 1986 to that in 1988?
Offer a very short reply. 0.88. What is the ratio of the Aid flow from UN agencies (US$) in Lao PDR in 1986 to that in 1988?
Keep it short and to the point. 0.03. What is the ratio of the Aid flow from UN agencies (US$) in Paraguay in 1986 to that in 1988?
Provide a succinct answer. 1.03. What is the ratio of the Aid flow from UN agencies (US$) in East Asia (all income levels) in 1986 to that in 1989?
Your response must be concise. 2.44. What is the ratio of the Aid flow from UN agencies (US$) of Middle East & North Africa (all income levels) in 1986 to that in 1989?
Your response must be concise. 0.98. What is the ratio of the Aid flow from UN agencies (US$) of Lao PDR in 1986 to that in 1989?
Provide a short and direct response. 0.14. What is the ratio of the Aid flow from UN agencies (US$) of Paraguay in 1986 to that in 1989?
Give a very brief answer. 0.66. What is the ratio of the Aid flow from UN agencies (US$) of East Asia (all income levels) in 1987 to that in 1988?
Offer a very short reply. 0.78. What is the ratio of the Aid flow from UN agencies (US$) of Middle East & North Africa (all income levels) in 1987 to that in 1988?
Offer a very short reply. 0.64. What is the ratio of the Aid flow from UN agencies (US$) in Lao PDR in 1987 to that in 1988?
Offer a terse response. 0.03. What is the ratio of the Aid flow from UN agencies (US$) of East Asia (all income levels) in 1987 to that in 1989?
Keep it short and to the point. 2.49. What is the ratio of the Aid flow from UN agencies (US$) in Middle East & North Africa (all income levels) in 1987 to that in 1989?
Provide a succinct answer. 0.72. What is the ratio of the Aid flow from UN agencies (US$) of Lao PDR in 1987 to that in 1989?
Provide a short and direct response. 0.13. What is the ratio of the Aid flow from UN agencies (US$) of Paraguay in 1987 to that in 1989?
Make the answer very short. 1.6. What is the ratio of the Aid flow from UN agencies (US$) in East Asia (all income levels) in 1988 to that in 1989?
Offer a very short reply. 3.18. What is the ratio of the Aid flow from UN agencies (US$) of Middle East & North Africa (all income levels) in 1988 to that in 1989?
Make the answer very short. 1.12. What is the ratio of the Aid flow from UN agencies (US$) of Lao PDR in 1988 to that in 1989?
Your response must be concise. 5.09. What is the ratio of the Aid flow from UN agencies (US$) in Paraguay in 1988 to that in 1989?
Give a very brief answer. 0.64. What is the difference between the highest and the second highest Aid flow from UN agencies (US$) of East Asia (all income levels)?
Offer a very short reply. 3.08e+07. What is the difference between the highest and the second highest Aid flow from UN agencies (US$) of Middle East & North Africa (all income levels)?
Offer a terse response. 8.64e+06. What is the difference between the highest and the second highest Aid flow from UN agencies (US$) of Lao PDR?
Give a very brief answer. 7.60e+06. What is the difference between the highest and the second highest Aid flow from UN agencies (US$) in Paraguay?
Make the answer very short. 1.06e+06. What is the difference between the highest and the lowest Aid flow from UN agencies (US$) of East Asia (all income levels)?
Keep it short and to the point. 9.72e+07. What is the difference between the highest and the lowest Aid flow from UN agencies (US$) in Middle East & North Africa (all income levels)?
Your response must be concise. 4.26e+07. What is the difference between the highest and the lowest Aid flow from UN agencies (US$) of Lao PDR?
Offer a very short reply. 9.28e+06. What is the difference between the highest and the lowest Aid flow from UN agencies (US$) of Paraguay?
Give a very brief answer. 2.65e+06. 